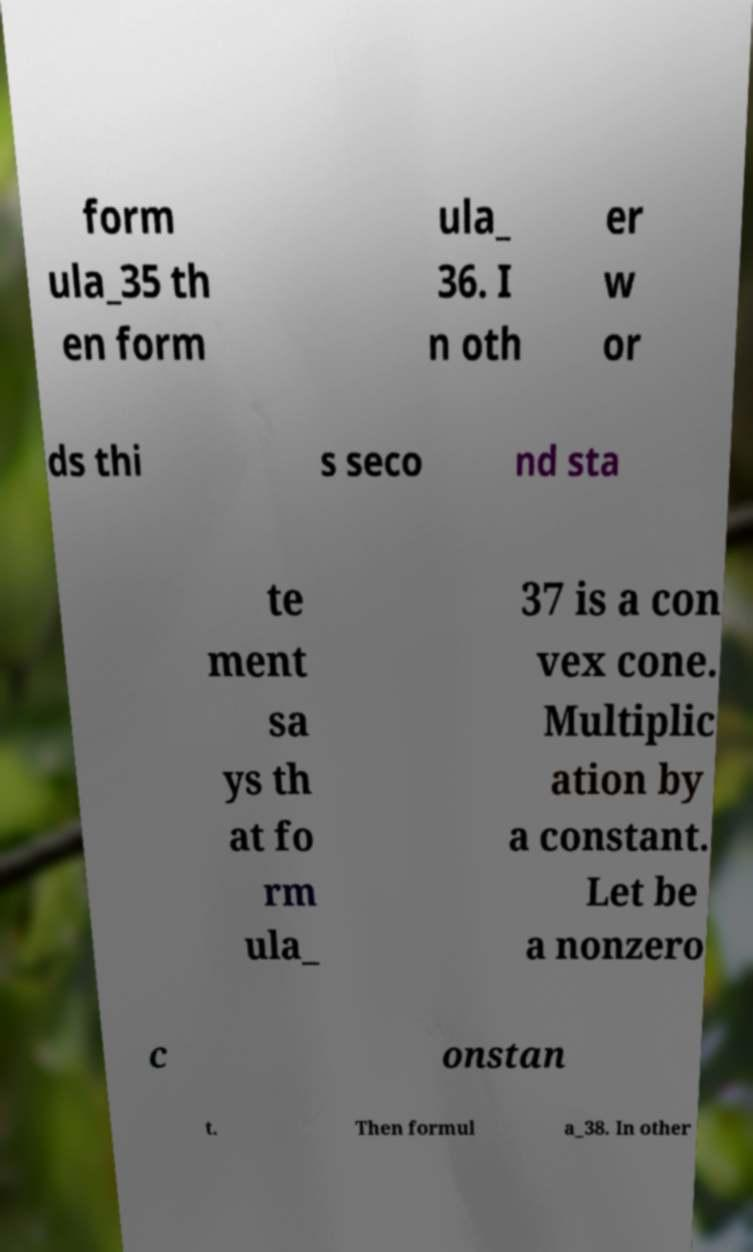For documentation purposes, I need the text within this image transcribed. Could you provide that? form ula_35 th en form ula_ 36. I n oth er w or ds thi s seco nd sta te ment sa ys th at fo rm ula_ 37 is a con vex cone. Multiplic ation by a constant. Let be a nonzero c onstan t. Then formul a_38. In other 